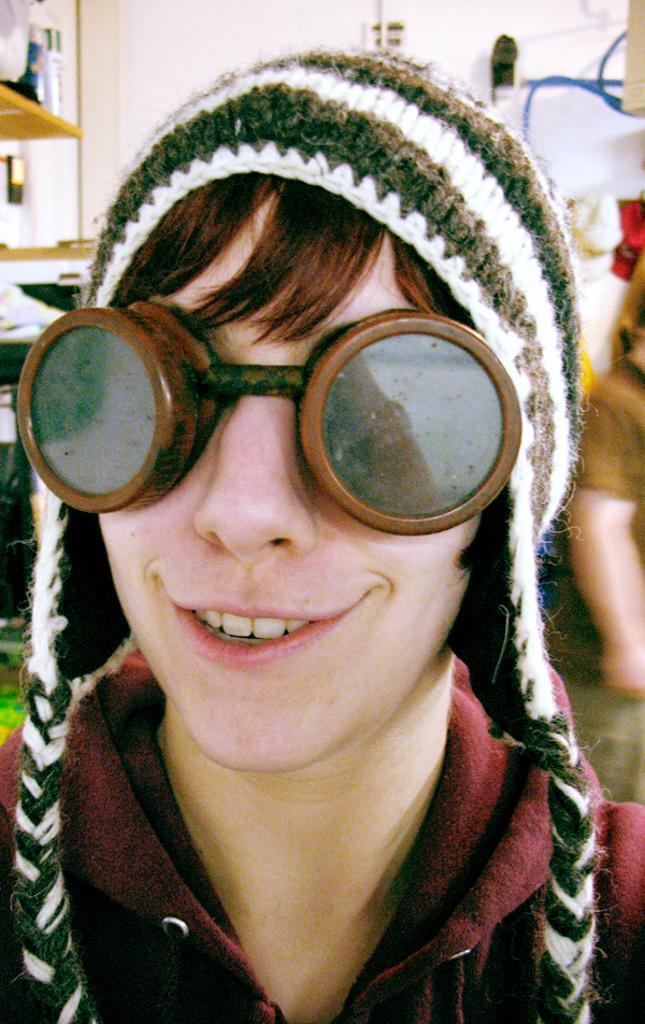Please provide a concise description of this image. In this image I can see a person taking the picture wearing glasses and a winter cap. And in the background there are some objects. 